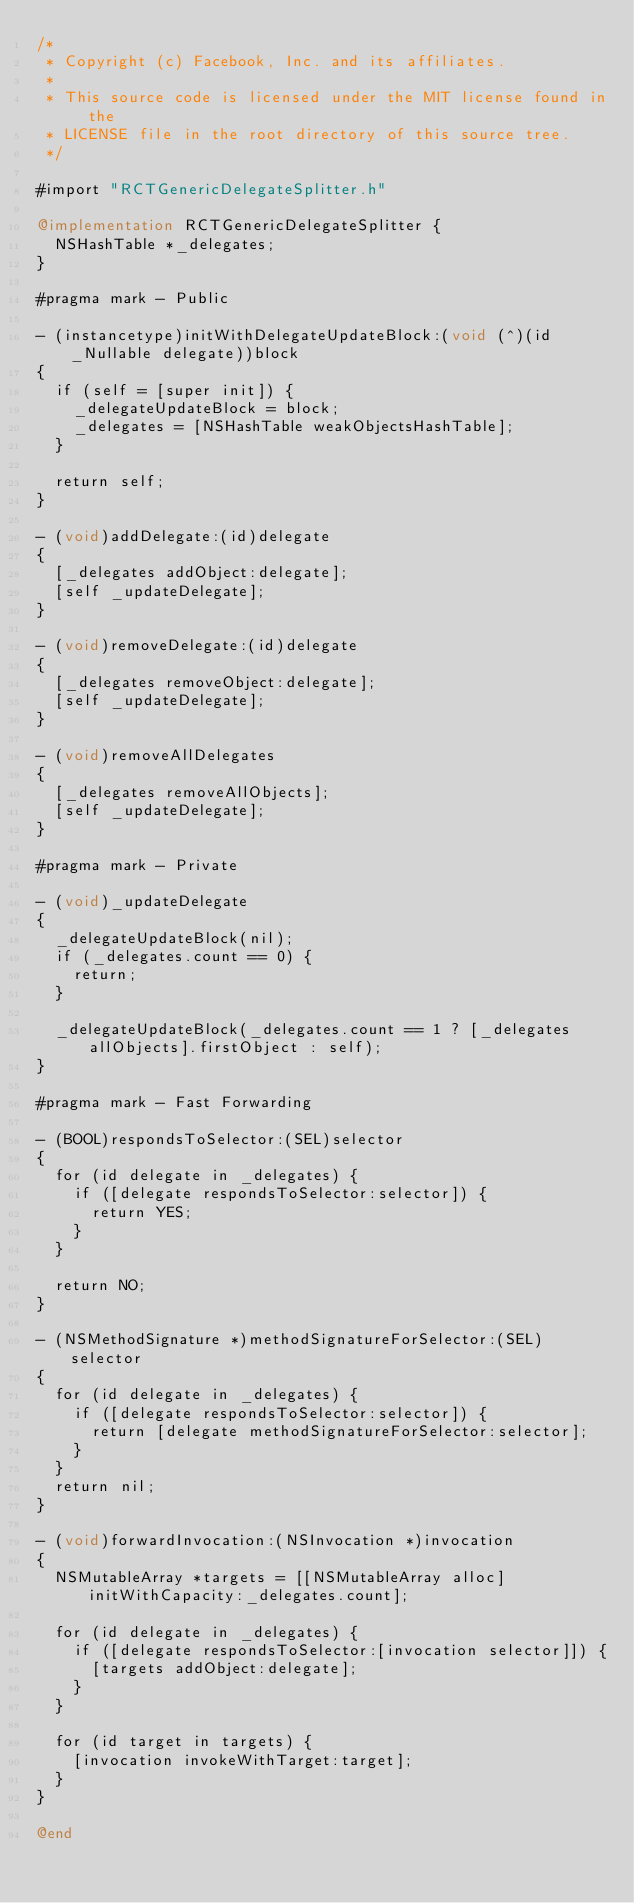<code> <loc_0><loc_0><loc_500><loc_500><_ObjectiveC_>/*
 * Copyright (c) Facebook, Inc. and its affiliates.
 *
 * This source code is licensed under the MIT license found in the
 * LICENSE file in the root directory of this source tree.
 */

#import "RCTGenericDelegateSplitter.h"

@implementation RCTGenericDelegateSplitter {
  NSHashTable *_delegates;
}

#pragma mark - Public

- (instancetype)initWithDelegateUpdateBlock:(void (^)(id _Nullable delegate))block
{
  if (self = [super init]) {
    _delegateUpdateBlock = block;
    _delegates = [NSHashTable weakObjectsHashTable];
  }

  return self;
}

- (void)addDelegate:(id)delegate
{
  [_delegates addObject:delegate];
  [self _updateDelegate];
}

- (void)removeDelegate:(id)delegate
{
  [_delegates removeObject:delegate];
  [self _updateDelegate];
}

- (void)removeAllDelegates
{
  [_delegates removeAllObjects];
  [self _updateDelegate];
}

#pragma mark - Private

- (void)_updateDelegate
{
  _delegateUpdateBlock(nil);
  if (_delegates.count == 0) {
    return;
  }

  _delegateUpdateBlock(_delegates.count == 1 ? [_delegates allObjects].firstObject : self);
}

#pragma mark - Fast Forwarding

- (BOOL)respondsToSelector:(SEL)selector
{
  for (id delegate in _delegates) {
    if ([delegate respondsToSelector:selector]) {
      return YES;
    }
  }

  return NO;
}

- (NSMethodSignature *)methodSignatureForSelector:(SEL)selector
{
  for (id delegate in _delegates) {
    if ([delegate respondsToSelector:selector]) {
      return [delegate methodSignatureForSelector:selector];
    }
  }
  return nil;
}

- (void)forwardInvocation:(NSInvocation *)invocation
{
  NSMutableArray *targets = [[NSMutableArray alloc] initWithCapacity:_delegates.count];

  for (id delegate in _delegates) {
    if ([delegate respondsToSelector:[invocation selector]]) {
      [targets addObject:delegate];
    }
  }

  for (id target in targets) {
    [invocation invokeWithTarget:target];
  }
}

@end
</code> 